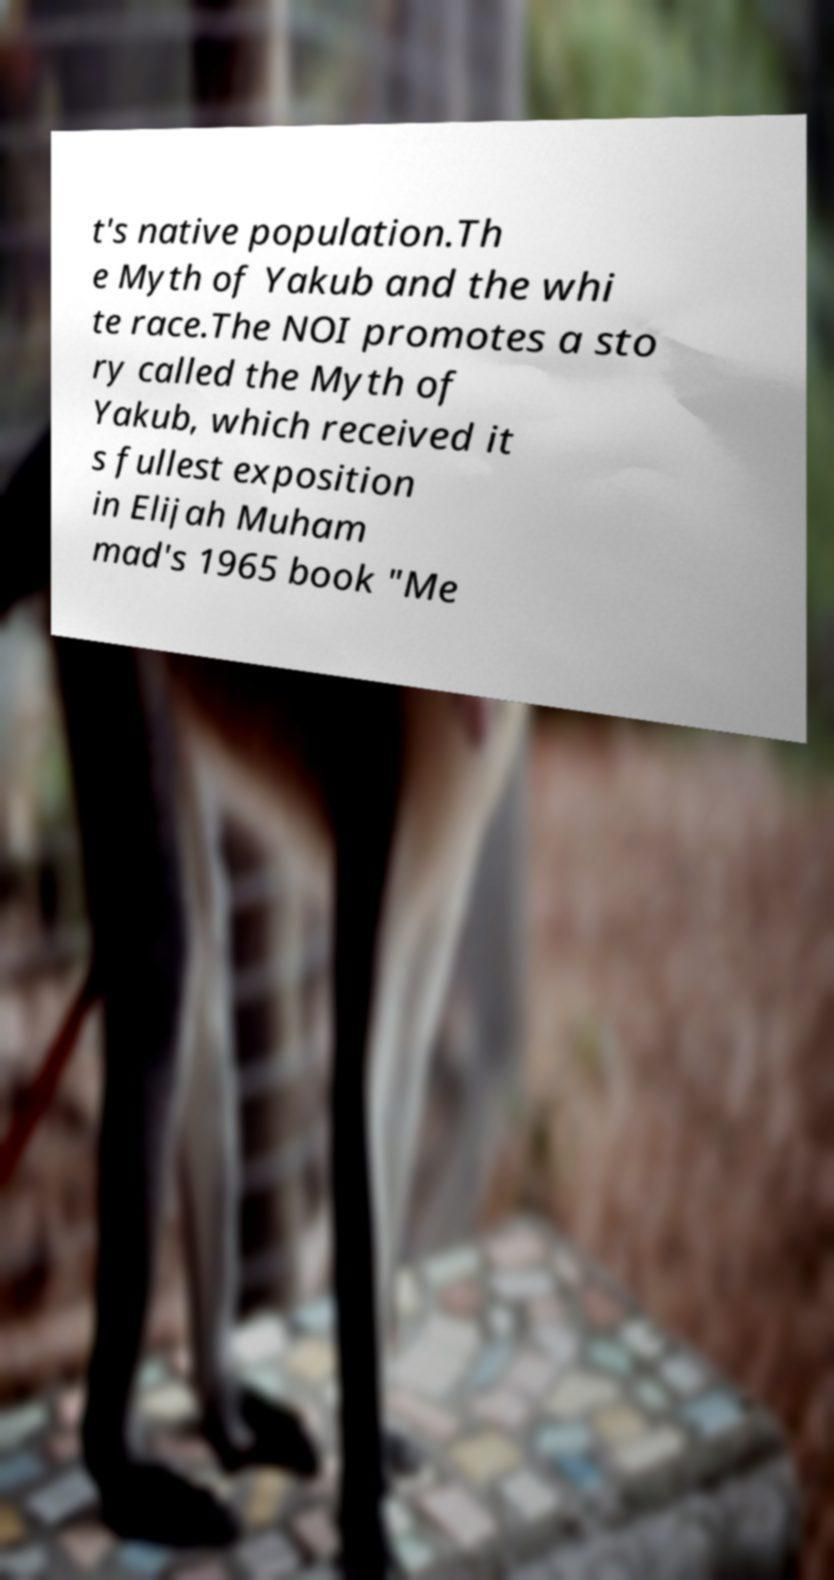Please identify and transcribe the text found in this image. t's native population.Th e Myth of Yakub and the whi te race.The NOI promotes a sto ry called the Myth of Yakub, which received it s fullest exposition in Elijah Muham mad's 1965 book "Me 